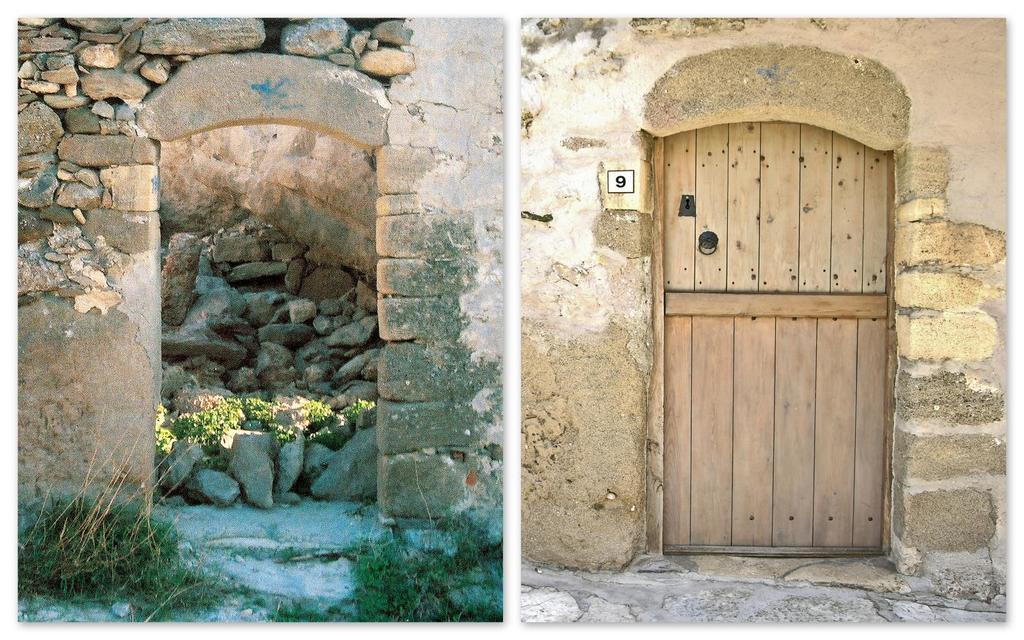What is on the wall in the image? There is a window on the wall in the image. What can be seen on the left side of the image? There is an entrance on the left side of the image. What is visible behind the entrance? There are rocks visible behind the entrance. What type of vegetation is present in the front of the image? There is some grass in the front of the image. What is the aftermath of the wall collapsing in the image? There is no indication of a wall collapsing in the image, so it is not possible to describe the aftermath. Can you guide me through the process of entering the building in the image? The image does not show a building, only an entrance with rocks behind it, so it is not possible to guide you through the process of entering a building. 